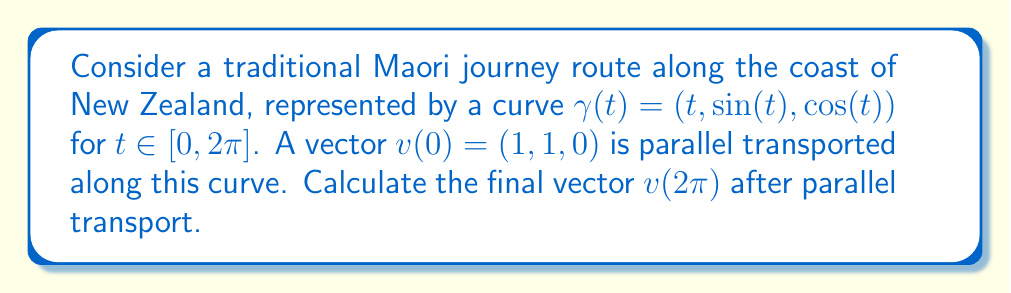Show me your answer to this math problem. To solve this problem, we'll follow these steps:

1) The parallel transport equation is given by:

   $$\frac{Dv}{dt} = 0$$

   where $\frac{D}{dt}$ is the covariant derivative along the curve.

2) For a curve in $\mathbb{R}^3$ with the standard metric, the parallel transport equation becomes:

   $$\frac{dv}{dt} + \Gamma v = 0$$

   where $\Gamma$ is the matrix of Christoffel symbols.

3) In $\mathbb{R}^3$ with the standard metric, all Christoffel symbols are zero. Therefore, the parallel transport equation simplifies to:

   $$\frac{dv}{dt} = 0$$

4) This means that the components of the vector remain constant along the curve. Therefore, the vector at the end of the curve will be the same as the initial vector:

   $$v(2\pi) = v(0) = (1, 1, 0)$$

5) We can verify this result by noting that parallel transport preserves the length of the vector and the angle between the vector and the tangent to the curve. The tangent vector to the curve is:

   $$T(t) = (1, \cos(t), -\sin(t))$$

   The inner product between $v(0)$ and $T(0)$ is:

   $$\langle v(0), T(0) \rangle = 1 \cdot 1 + 1 \cdot 1 + 0 \cdot 0 = 2$$

   This should be preserved at $t = 2\pi$:

   $$\langle v(2\pi), T(2\pi) \rangle = 1 \cdot 1 + 1 \cdot 1 + 0 \cdot 0 = 2$$

   which confirms our result.
Answer: $v(2\pi) = (1, 1, 0)$ 